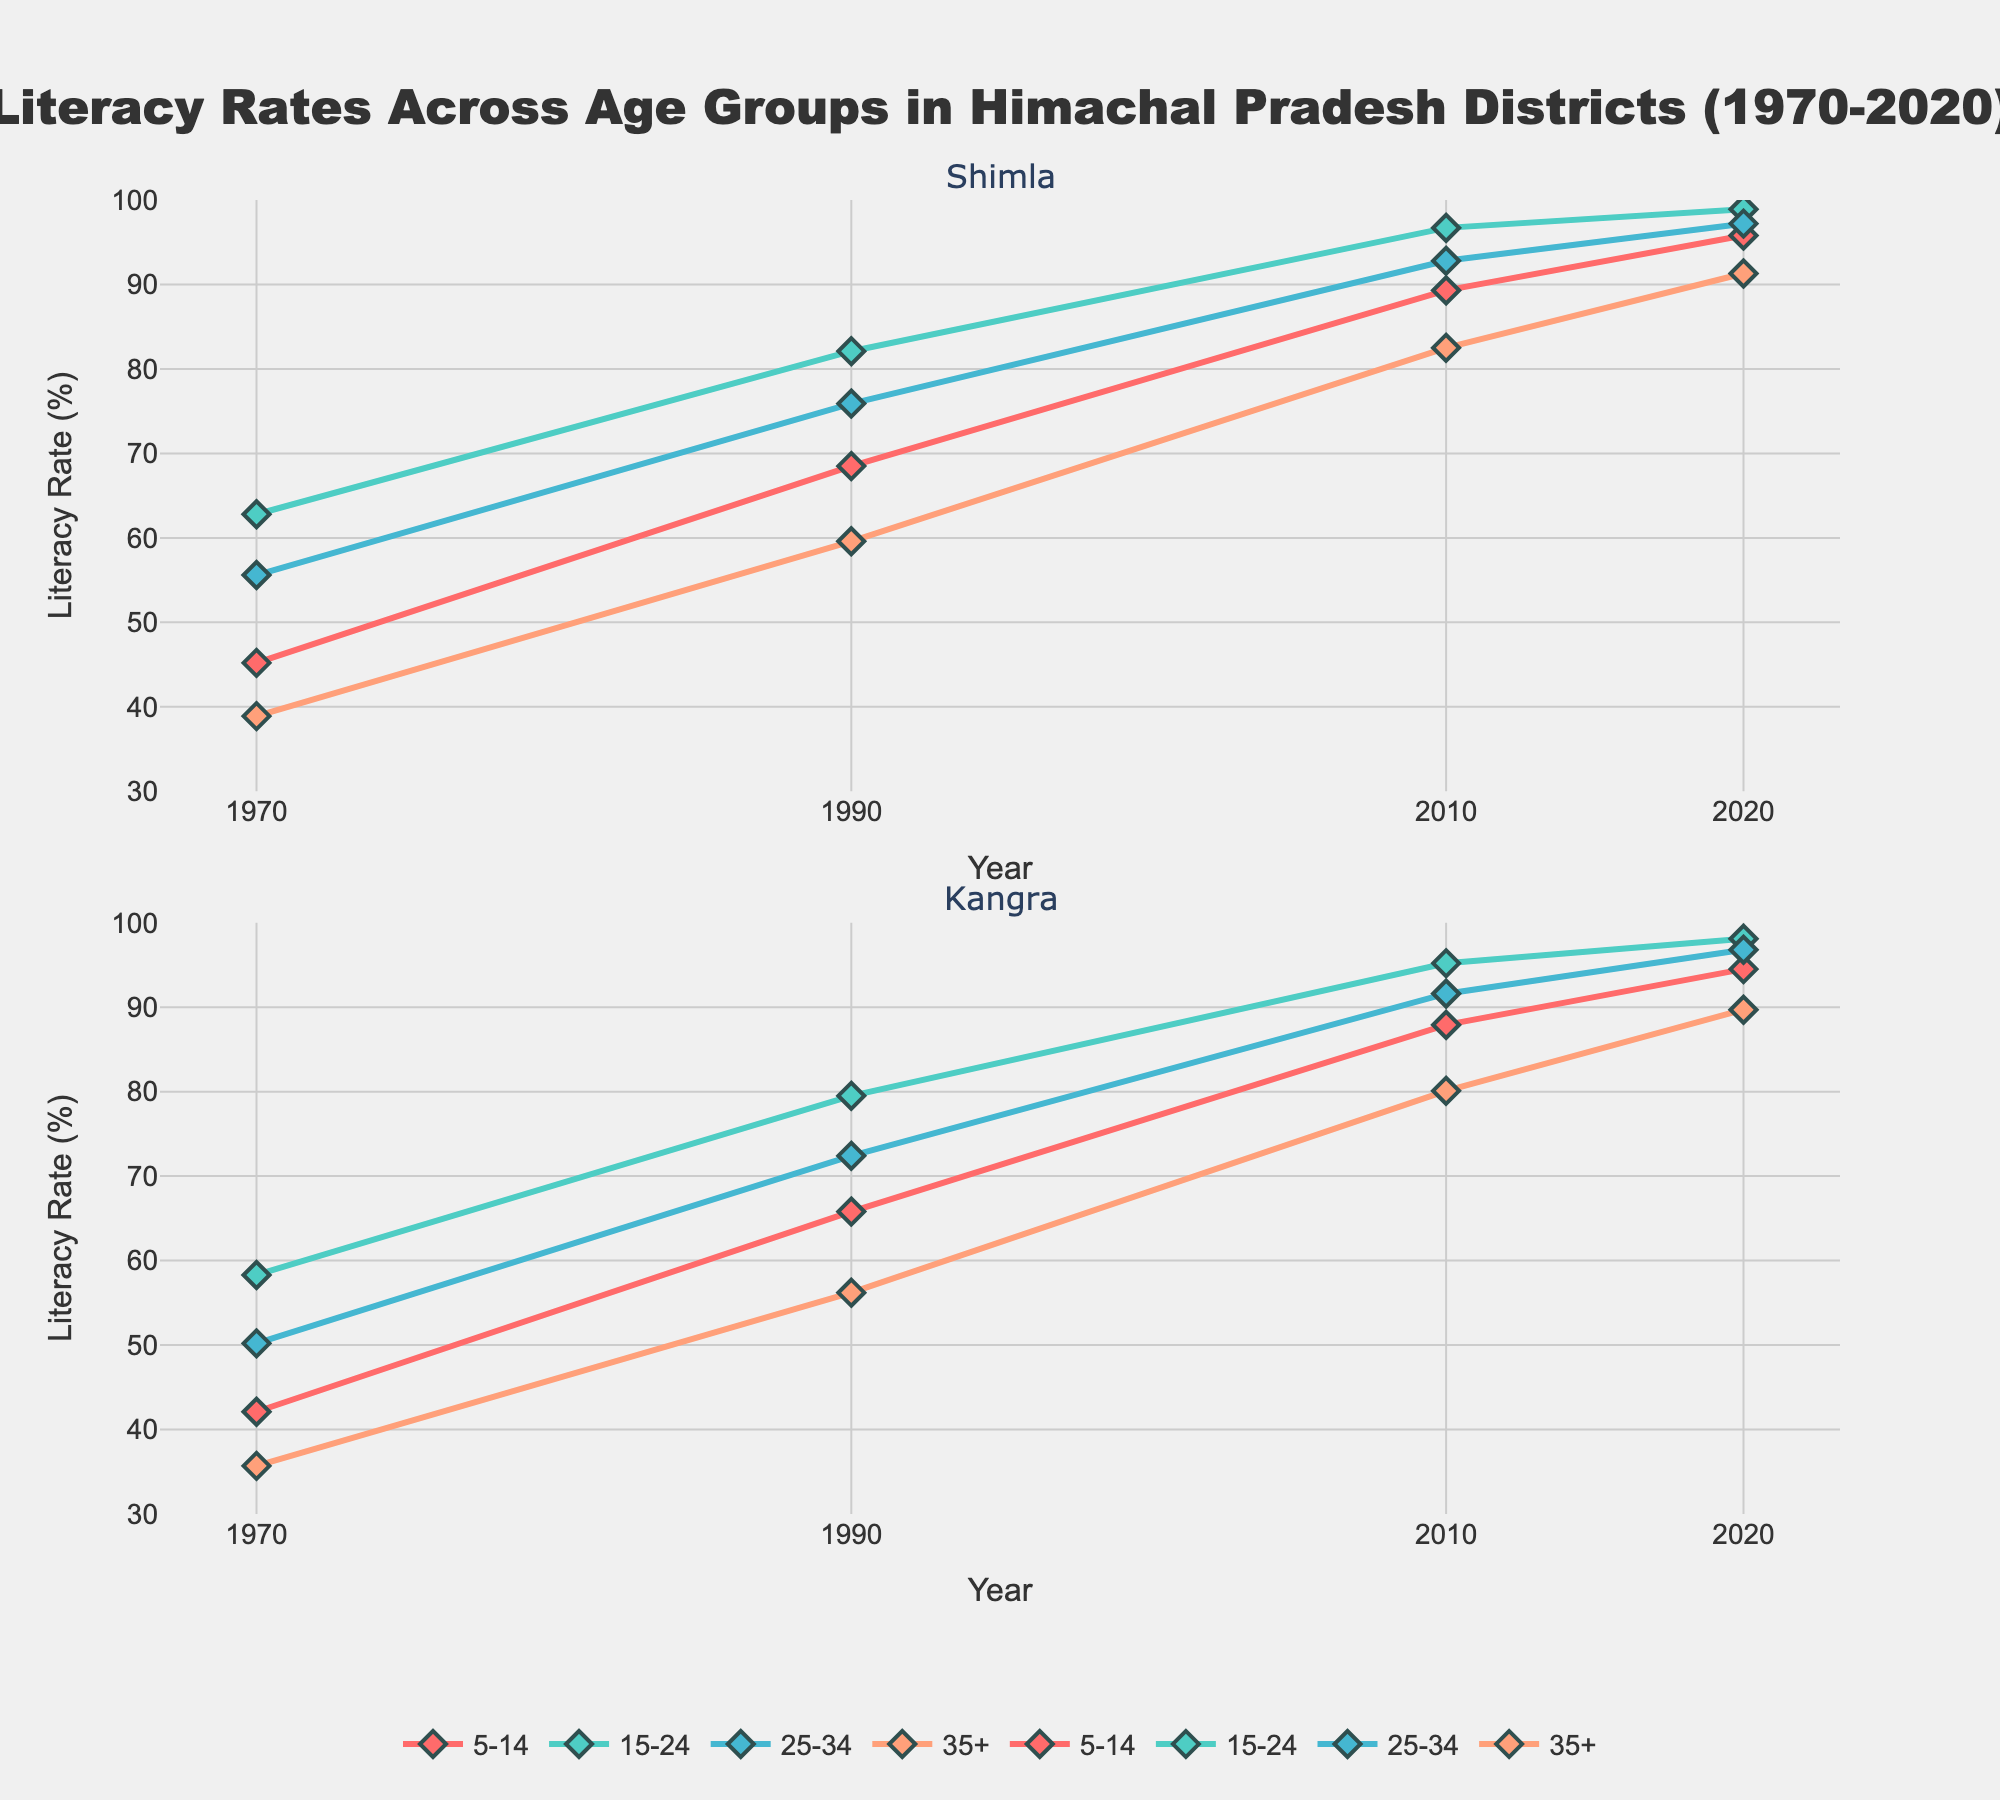Which artist has the highest album sales in the Country genre? The plot for the Country genre shows the horizontal bars representing different artists. Locate the longest bar in the Country genre subplot, which belongs to Garth Brooks with 3.5 million album sales.
Answer: Garth Brooks How many artists have higher album sales in Pop than in Country? For each artist, compare the Pop and Country sales by visually inspecting the horizontal bars in both subplots. Taylor Swift (2.5 > 1.2), Beyoncé (1.8 > 0.1), Drake (0.7 > 0.1), and Adele (2.1 > 0.2) have higher Pop sales. Eminem has equal sales for both genres.
Answer: 4 What is the sum of album sales across all genres for Taylor Swift? Add the sales values for Taylor Swift in all genres: Pop (2.5) + Rock (0.8) + Country (1.2) + Hip-Hop (0.1) + R&B (0.3).
Answer: 4.9 million Who are the two artists with the highest album sales in the Hip-Hop genre? The plot for the Hip-Hop genre shows horizontal bars. The longest bars belong to Eminem (2.8) and Drake (2.5).
Answer: Eminem and Drake Which artist has sold the least number of albums in Rock? Check the shortest bar in the Rock genre subplot to find that Luke Bryan has the least album sales with 0.1 million.
Answer: Luke Bryan Between Adele and Beyoncé, who has higher album sales in R&B? Compare the bars in the R&B genre subplot for Adele and Beyoncé. Adele has 1.1 million and Beyoncé has 1.5 million.
Answer: Beyoncé Is there any artist who has sold over 2 million albums in more than one genre? Check each artist to see if any of their bars in any subplot exceed 2 million. Taylor Swift (Pop and Country) and Eminem (Hip-Hop) have more than 2 million in at least one genre, but no single artist exceeds 2 million in more than one genre.
Answer: No Rank the artists by their album sales in Rock from highest to lowest. Observe the bars in the Rock subplot and order them: Kings of Leon (1.9), Taylor Swift (0.8), Adele (0.5), Beyoncé (0.3), Garth Brooks (0.2), Eminem (0.2), Drake (0.1), Luke Bryan (0.1).
Answer: Kings of Leon, Taylor Swift, Adele, Beyoncé, Garth Brooks, Eminem, Drake, Luke Bryan Which genre shows the highest variance in album sales among the artists? For each genre subplot, compare the range of album sales by identifying the largest gap between the highest and lowest values. The Country genre has the highest range with Garth Brooks (3.5) and several artists with < 1 million.
Answer: Country 